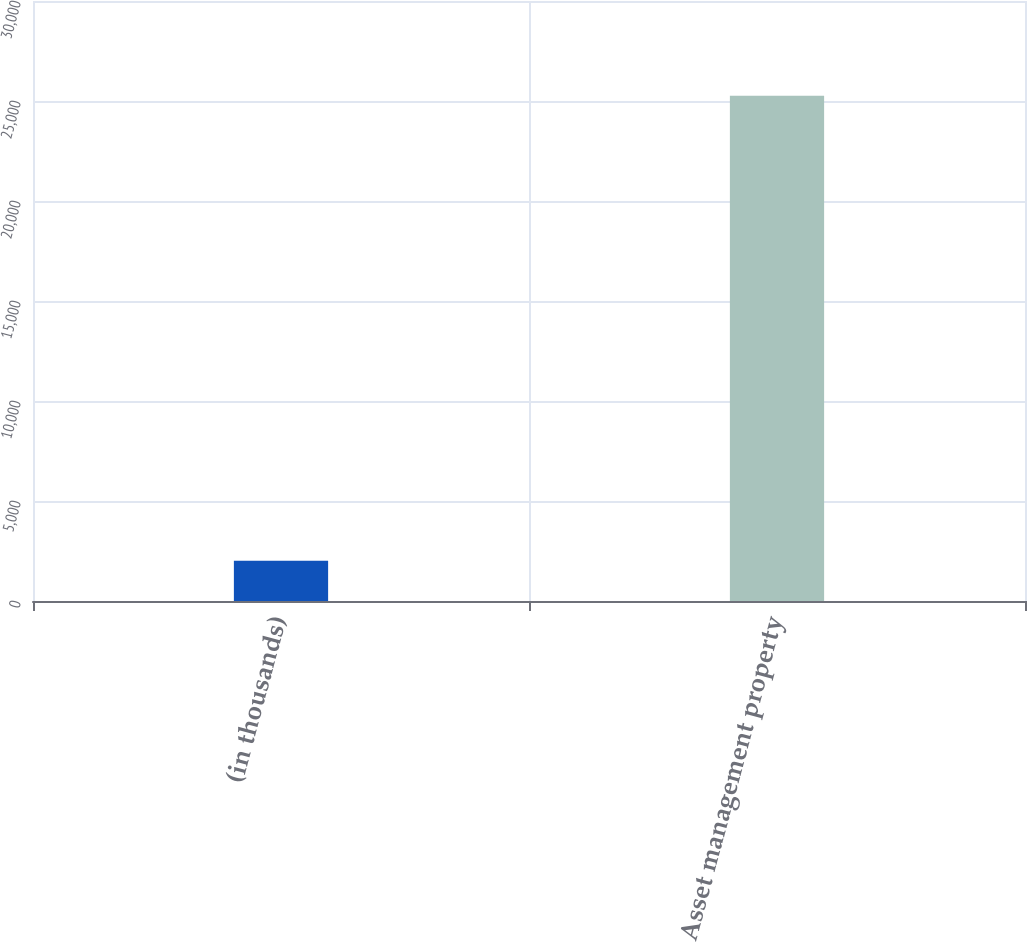Convert chart. <chart><loc_0><loc_0><loc_500><loc_500><bar_chart><fcel>(in thousands)<fcel>Asset management property<nl><fcel>2017<fcel>25260<nl></chart> 